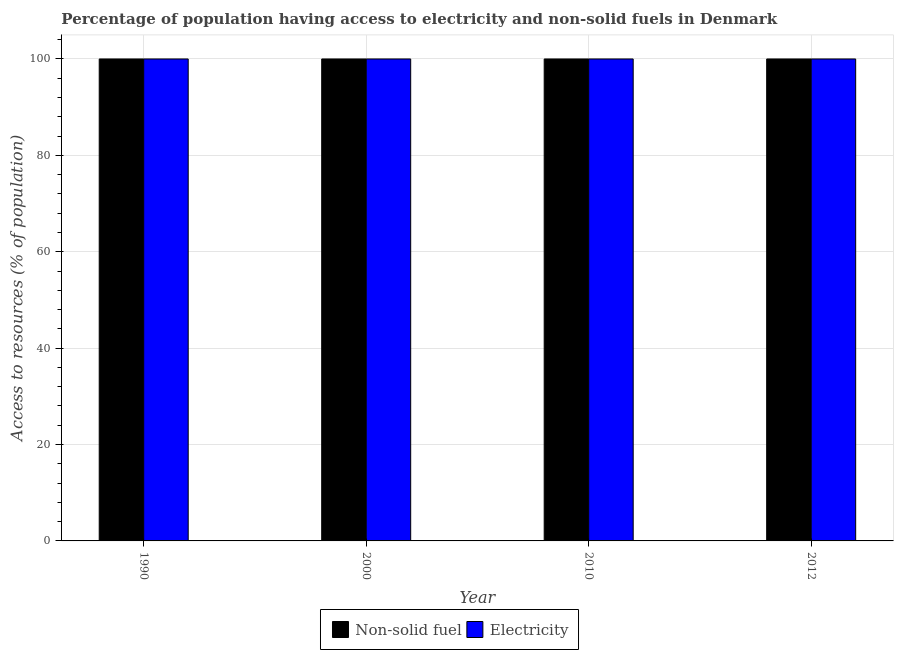How many groups of bars are there?
Provide a short and direct response. 4. Are the number of bars per tick equal to the number of legend labels?
Offer a very short reply. Yes. What is the label of the 2nd group of bars from the left?
Ensure brevity in your answer.  2000. What is the percentage of population having access to non-solid fuel in 1990?
Your response must be concise. 100. Across all years, what is the maximum percentage of population having access to non-solid fuel?
Ensure brevity in your answer.  100. Across all years, what is the minimum percentage of population having access to non-solid fuel?
Make the answer very short. 100. In which year was the percentage of population having access to non-solid fuel minimum?
Provide a succinct answer. 1990. What is the total percentage of population having access to non-solid fuel in the graph?
Keep it short and to the point. 400. What is the difference between the percentage of population having access to non-solid fuel in 1990 and the percentage of population having access to electricity in 2012?
Provide a succinct answer. 0. What is the average percentage of population having access to electricity per year?
Ensure brevity in your answer.  100. In how many years, is the percentage of population having access to non-solid fuel greater than 16 %?
Your answer should be very brief. 4. What is the ratio of the percentage of population having access to non-solid fuel in 2000 to that in 2010?
Your answer should be very brief. 1. Is the percentage of population having access to non-solid fuel in 2010 less than that in 2012?
Your answer should be compact. No. Is the difference between the percentage of population having access to non-solid fuel in 2000 and 2012 greater than the difference between the percentage of population having access to electricity in 2000 and 2012?
Offer a very short reply. No. What is the difference between the highest and the lowest percentage of population having access to electricity?
Your answer should be compact. 0. In how many years, is the percentage of population having access to non-solid fuel greater than the average percentage of population having access to non-solid fuel taken over all years?
Offer a very short reply. 0. What does the 2nd bar from the left in 1990 represents?
Your response must be concise. Electricity. What does the 2nd bar from the right in 2010 represents?
Make the answer very short. Non-solid fuel. Are all the bars in the graph horizontal?
Your response must be concise. No. Are the values on the major ticks of Y-axis written in scientific E-notation?
Make the answer very short. No. Does the graph contain any zero values?
Offer a very short reply. No. Does the graph contain grids?
Provide a succinct answer. Yes. What is the title of the graph?
Provide a short and direct response. Percentage of population having access to electricity and non-solid fuels in Denmark. Does "Primary income" appear as one of the legend labels in the graph?
Make the answer very short. No. What is the label or title of the Y-axis?
Offer a very short reply. Access to resources (% of population). What is the Access to resources (% of population) in Electricity in 1990?
Your answer should be very brief. 100. What is the Access to resources (% of population) of Electricity in 2000?
Provide a succinct answer. 100. What is the Access to resources (% of population) of Non-solid fuel in 2010?
Provide a short and direct response. 100. What is the Access to resources (% of population) in Electricity in 2010?
Your answer should be compact. 100. What is the Access to resources (% of population) of Electricity in 2012?
Your answer should be compact. 100. What is the total Access to resources (% of population) in Non-solid fuel in the graph?
Offer a very short reply. 400. What is the total Access to resources (% of population) of Electricity in the graph?
Your answer should be very brief. 400. What is the difference between the Access to resources (% of population) in Non-solid fuel in 1990 and that in 2010?
Offer a terse response. 0. What is the difference between the Access to resources (% of population) of Non-solid fuel in 2000 and that in 2012?
Your answer should be compact. 0. What is the difference between the Access to resources (% of population) in Non-solid fuel in 2010 and that in 2012?
Make the answer very short. 0. What is the difference between the Access to resources (% of population) of Non-solid fuel in 1990 and the Access to resources (% of population) of Electricity in 2000?
Make the answer very short. 0. What is the difference between the Access to resources (% of population) of Non-solid fuel in 1990 and the Access to resources (% of population) of Electricity in 2012?
Offer a very short reply. 0. What is the difference between the Access to resources (% of population) of Non-solid fuel in 2000 and the Access to resources (% of population) of Electricity in 2010?
Give a very brief answer. 0. What is the difference between the Access to resources (% of population) of Non-solid fuel in 2000 and the Access to resources (% of population) of Electricity in 2012?
Offer a terse response. 0. In the year 2000, what is the difference between the Access to resources (% of population) of Non-solid fuel and Access to resources (% of population) of Electricity?
Provide a short and direct response. 0. In the year 2010, what is the difference between the Access to resources (% of population) in Non-solid fuel and Access to resources (% of population) in Electricity?
Give a very brief answer. 0. In the year 2012, what is the difference between the Access to resources (% of population) of Non-solid fuel and Access to resources (% of population) of Electricity?
Provide a succinct answer. 0. What is the ratio of the Access to resources (% of population) of Electricity in 1990 to that in 2000?
Ensure brevity in your answer.  1. What is the ratio of the Access to resources (% of population) of Electricity in 1990 to that in 2010?
Provide a short and direct response. 1. What is the ratio of the Access to resources (% of population) of Electricity in 1990 to that in 2012?
Give a very brief answer. 1. What is the ratio of the Access to resources (% of population) in Non-solid fuel in 2000 to that in 2012?
Keep it short and to the point. 1. What is the difference between the highest and the second highest Access to resources (% of population) in Electricity?
Provide a succinct answer. 0. What is the difference between the highest and the lowest Access to resources (% of population) of Non-solid fuel?
Provide a short and direct response. 0. What is the difference between the highest and the lowest Access to resources (% of population) of Electricity?
Provide a succinct answer. 0. 